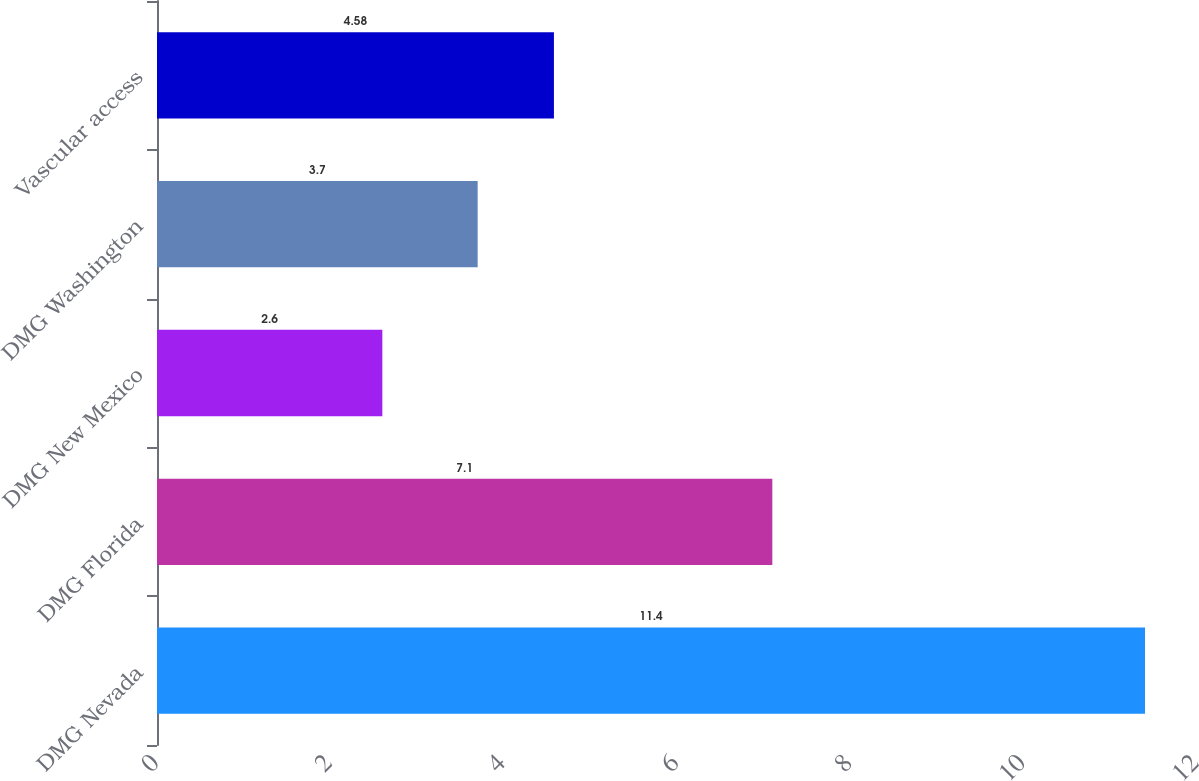<chart> <loc_0><loc_0><loc_500><loc_500><bar_chart><fcel>DMG Nevada<fcel>DMG Florida<fcel>DMG New Mexico<fcel>DMG Washington<fcel>Vascular access<nl><fcel>11.4<fcel>7.1<fcel>2.6<fcel>3.7<fcel>4.58<nl></chart> 